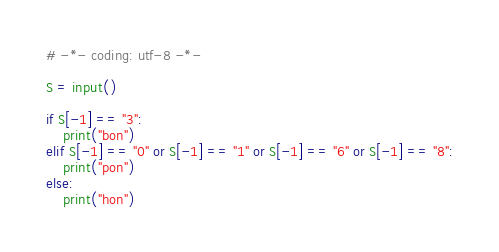<code> <loc_0><loc_0><loc_500><loc_500><_Python_># -*- coding: utf-8 -*-

S = input()

if S[-1] == "3":
    print("bon")
elif S[-1] == "0" or S[-1] == "1" or S[-1] == "6" or S[-1] == "8":
    print("pon")
else:
    print("hon")
</code> 